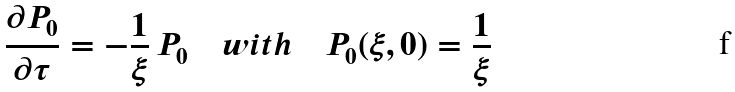<formula> <loc_0><loc_0><loc_500><loc_500>\frac { \partial P _ { 0 } } { \partial \tau } = - \frac { 1 } { \xi } \, P _ { 0 } \quad w i t h \quad P _ { 0 } ( \xi , 0 ) = \frac { 1 } { \xi }</formula> 